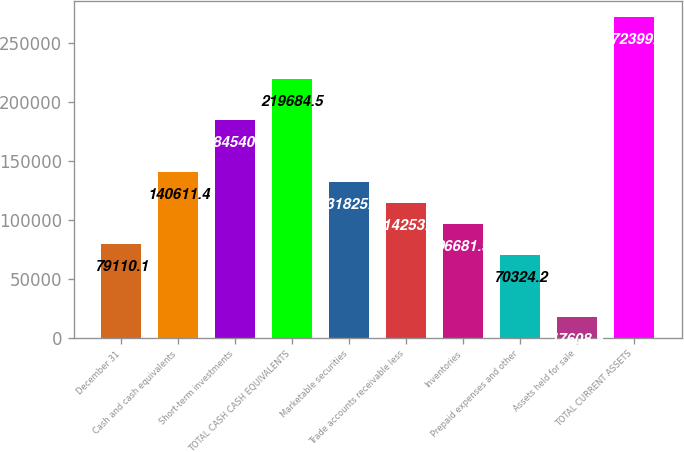Convert chart. <chart><loc_0><loc_0><loc_500><loc_500><bar_chart><fcel>December 31<fcel>Cash and cash equivalents<fcel>Short-term investments<fcel>TOTAL CASH CASH EQUIVALENTS<fcel>Marketable securities<fcel>Trade accounts receivable less<fcel>Inventories<fcel>Prepaid expenses and other<fcel>Assets held for sale<fcel>TOTAL CURRENT ASSETS<nl><fcel>79110.1<fcel>140611<fcel>184541<fcel>219684<fcel>131826<fcel>114254<fcel>96681.9<fcel>70324.2<fcel>17608.8<fcel>272400<nl></chart> 